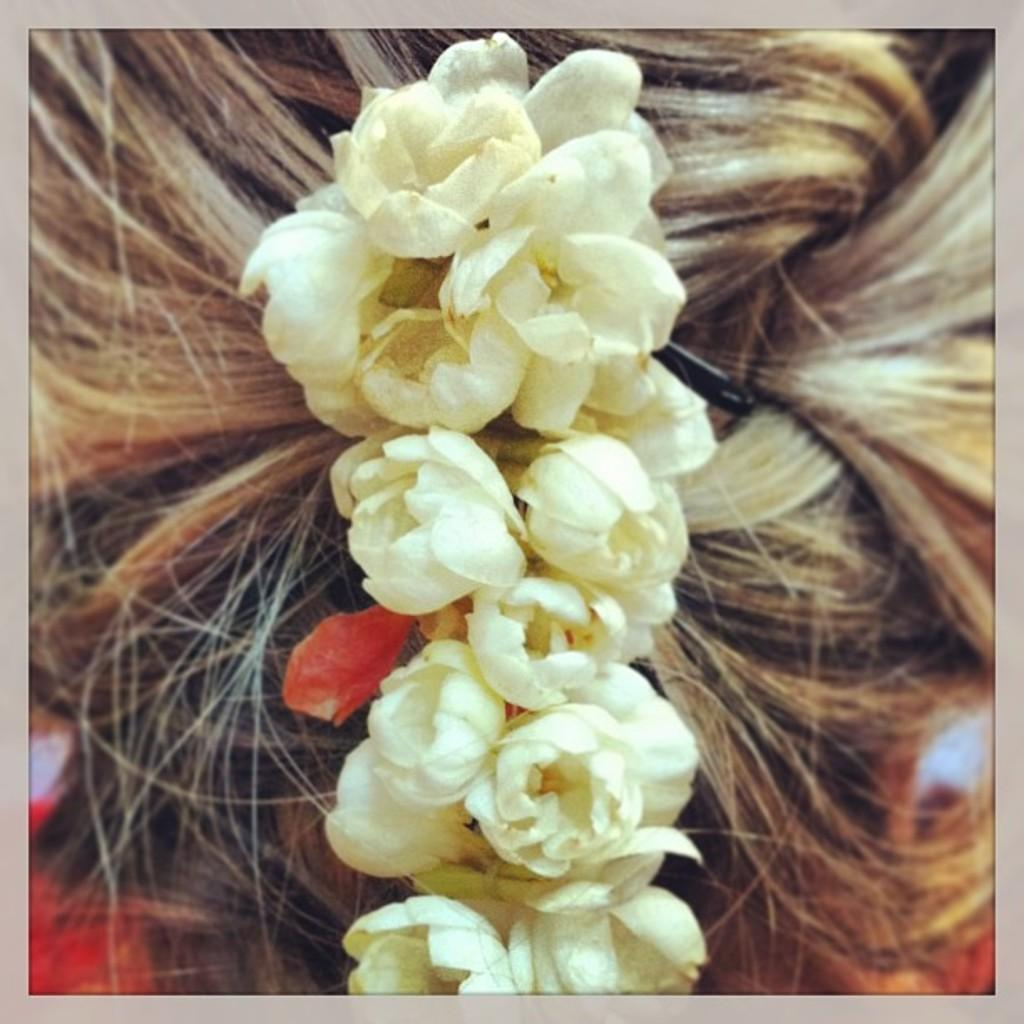What type of garland is visible in the image? There is a garland made of jasmine flowers in the image. Where is the garland placed on the girl? The garland is on a girl's plait. How many babies are visible in the image? There are no babies present in the image. What type of apparatus is used to secure the garland on the girl's plait? There is no apparatus visible in the image; the garland is simply placed on the girl's plait. 